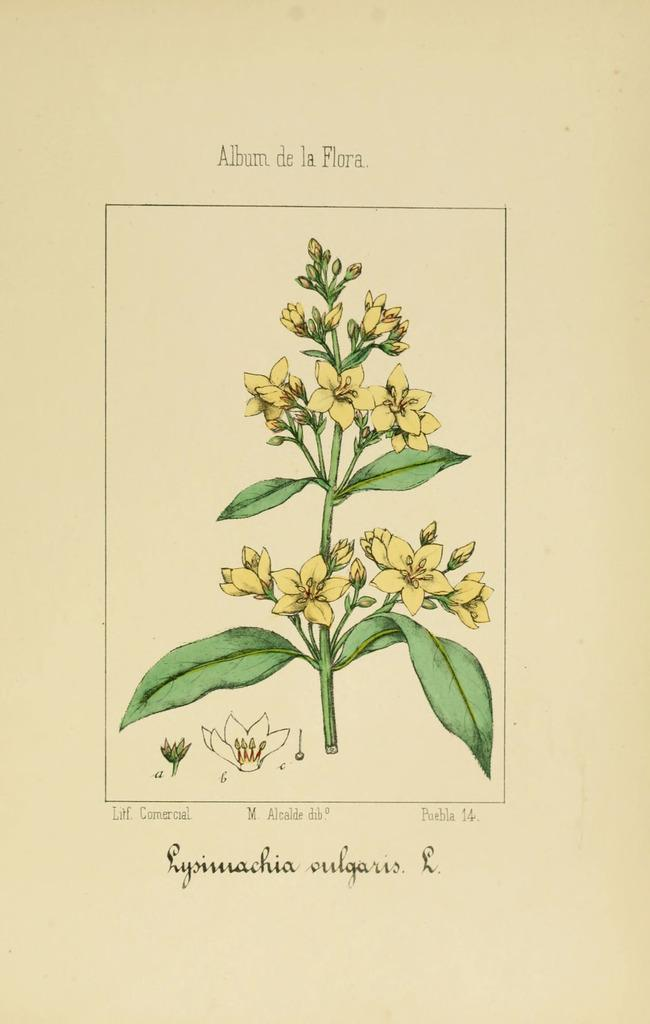What type of flora can be seen on the page? The page contains flowers and a plant. What else is present on the page besides the flora? There is text on the page. What type of beef is being served for the meal on the page? There is no mention of beef or a meal on the page; it contains flowers, a plant, and text. 